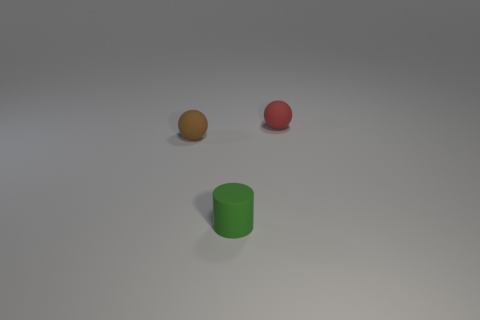Add 2 blocks. How many objects exist? 5 Subtract all brown spheres. How many spheres are left? 1 Subtract 0 yellow cylinders. How many objects are left? 3 Subtract all spheres. How many objects are left? 1 Subtract all yellow cylinders. Subtract all red cubes. How many cylinders are left? 1 Subtract all small matte things. Subtract all large yellow balls. How many objects are left? 0 Add 1 red rubber spheres. How many red rubber spheres are left? 2 Add 2 tiny brown cubes. How many tiny brown cubes exist? 2 